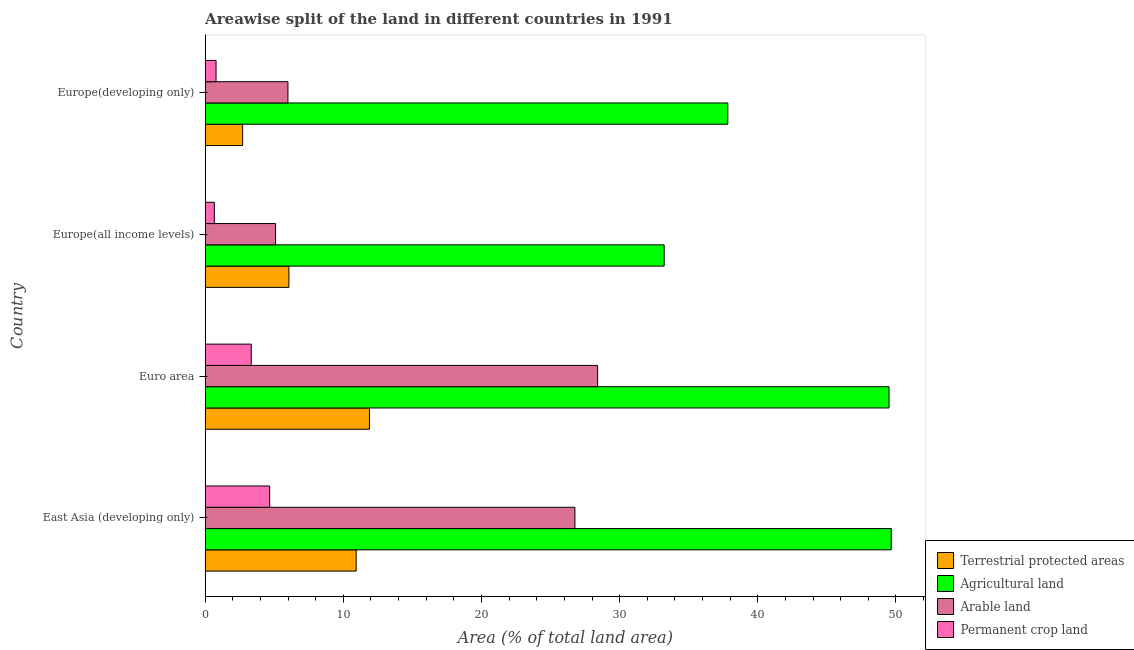How many different coloured bars are there?
Make the answer very short. 4. How many bars are there on the 4th tick from the top?
Make the answer very short. 4. How many bars are there on the 4th tick from the bottom?
Your answer should be very brief. 4. What is the label of the 1st group of bars from the top?
Offer a very short reply. Europe(developing only). What is the percentage of area under agricultural land in Europe(developing only)?
Provide a short and direct response. 37.83. Across all countries, what is the maximum percentage of land under terrestrial protection?
Offer a very short reply. 11.89. Across all countries, what is the minimum percentage of area under permanent crop land?
Make the answer very short. 0.66. In which country was the percentage of land under terrestrial protection minimum?
Keep it short and to the point. Europe(developing only). What is the total percentage of area under arable land in the graph?
Offer a terse response. 66.25. What is the difference between the percentage of area under permanent crop land in East Asia (developing only) and that in Europe(developing only)?
Provide a short and direct response. 3.88. What is the difference between the percentage of area under permanent crop land in Euro area and the percentage of land under terrestrial protection in East Asia (developing only)?
Give a very brief answer. -7.59. What is the average percentage of area under arable land per country?
Ensure brevity in your answer.  16.56. What is the difference between the percentage of area under arable land and percentage of land under terrestrial protection in East Asia (developing only)?
Give a very brief answer. 15.83. What is the ratio of the percentage of area under permanent crop land in East Asia (developing only) to that in Europe(developing only)?
Provide a succinct answer. 5.94. What is the difference between the highest and the second highest percentage of area under arable land?
Give a very brief answer. 1.64. What is the difference between the highest and the lowest percentage of area under arable land?
Keep it short and to the point. 23.31. Is the sum of the percentage of area under permanent crop land in Euro area and Europe(developing only) greater than the maximum percentage of area under agricultural land across all countries?
Give a very brief answer. No. Is it the case that in every country, the sum of the percentage of land under terrestrial protection and percentage of area under arable land is greater than the sum of percentage of area under permanent crop land and percentage of area under agricultural land?
Provide a succinct answer. No. What does the 2nd bar from the top in Euro area represents?
Offer a very short reply. Arable land. What does the 1st bar from the bottom in Europe(all income levels) represents?
Your response must be concise. Terrestrial protected areas. Is it the case that in every country, the sum of the percentage of land under terrestrial protection and percentage of area under agricultural land is greater than the percentage of area under arable land?
Make the answer very short. Yes. How many bars are there?
Make the answer very short. 16. How many countries are there in the graph?
Provide a short and direct response. 4. Does the graph contain any zero values?
Your response must be concise. No. Where does the legend appear in the graph?
Give a very brief answer. Bottom right. How many legend labels are there?
Your answer should be compact. 4. What is the title of the graph?
Your answer should be very brief. Areawise split of the land in different countries in 1991. What is the label or title of the X-axis?
Provide a succinct answer. Area (% of total land area). What is the label or title of the Y-axis?
Your response must be concise. Country. What is the Area (% of total land area) in Terrestrial protected areas in East Asia (developing only)?
Keep it short and to the point. 10.93. What is the Area (% of total land area) in Agricultural land in East Asia (developing only)?
Make the answer very short. 49.66. What is the Area (% of total land area) of Arable land in East Asia (developing only)?
Provide a short and direct response. 26.76. What is the Area (% of total land area) in Permanent crop land in East Asia (developing only)?
Keep it short and to the point. 4.67. What is the Area (% of total land area) of Terrestrial protected areas in Euro area?
Provide a succinct answer. 11.89. What is the Area (% of total land area) in Agricultural land in Euro area?
Offer a very short reply. 49.5. What is the Area (% of total land area) in Arable land in Euro area?
Provide a succinct answer. 28.41. What is the Area (% of total land area) of Permanent crop land in Euro area?
Offer a terse response. 3.33. What is the Area (% of total land area) in Terrestrial protected areas in Europe(all income levels)?
Provide a short and direct response. 6.06. What is the Area (% of total land area) of Agricultural land in Europe(all income levels)?
Your response must be concise. 33.22. What is the Area (% of total land area) in Arable land in Europe(all income levels)?
Give a very brief answer. 5.09. What is the Area (% of total land area) of Permanent crop land in Europe(all income levels)?
Keep it short and to the point. 0.66. What is the Area (% of total land area) of Terrestrial protected areas in Europe(developing only)?
Provide a short and direct response. 2.71. What is the Area (% of total land area) in Agricultural land in Europe(developing only)?
Your answer should be very brief. 37.83. What is the Area (% of total land area) in Arable land in Europe(developing only)?
Give a very brief answer. 5.99. What is the Area (% of total land area) of Permanent crop land in Europe(developing only)?
Make the answer very short. 0.79. Across all countries, what is the maximum Area (% of total land area) in Terrestrial protected areas?
Give a very brief answer. 11.89. Across all countries, what is the maximum Area (% of total land area) in Agricultural land?
Your answer should be very brief. 49.66. Across all countries, what is the maximum Area (% of total land area) of Arable land?
Your response must be concise. 28.41. Across all countries, what is the maximum Area (% of total land area) in Permanent crop land?
Give a very brief answer. 4.67. Across all countries, what is the minimum Area (% of total land area) of Terrestrial protected areas?
Provide a short and direct response. 2.71. Across all countries, what is the minimum Area (% of total land area) of Agricultural land?
Keep it short and to the point. 33.22. Across all countries, what is the minimum Area (% of total land area) in Arable land?
Your answer should be compact. 5.09. Across all countries, what is the minimum Area (% of total land area) in Permanent crop land?
Offer a terse response. 0.66. What is the total Area (% of total land area) of Terrestrial protected areas in the graph?
Give a very brief answer. 31.59. What is the total Area (% of total land area) of Agricultural land in the graph?
Offer a very short reply. 170.21. What is the total Area (% of total land area) of Arable land in the graph?
Your answer should be compact. 66.25. What is the total Area (% of total land area) of Permanent crop land in the graph?
Your answer should be very brief. 9.45. What is the difference between the Area (% of total land area) of Terrestrial protected areas in East Asia (developing only) and that in Euro area?
Provide a short and direct response. -0.96. What is the difference between the Area (% of total land area) of Agricultural land in East Asia (developing only) and that in Euro area?
Give a very brief answer. 0.16. What is the difference between the Area (% of total land area) of Arable land in East Asia (developing only) and that in Euro area?
Your answer should be very brief. -1.64. What is the difference between the Area (% of total land area) in Permanent crop land in East Asia (developing only) and that in Euro area?
Provide a short and direct response. 1.33. What is the difference between the Area (% of total land area) of Terrestrial protected areas in East Asia (developing only) and that in Europe(all income levels)?
Ensure brevity in your answer.  4.87. What is the difference between the Area (% of total land area) of Agricultural land in East Asia (developing only) and that in Europe(all income levels)?
Give a very brief answer. 16.44. What is the difference between the Area (% of total land area) of Arable land in East Asia (developing only) and that in Europe(all income levels)?
Offer a very short reply. 21.67. What is the difference between the Area (% of total land area) in Permanent crop land in East Asia (developing only) and that in Europe(all income levels)?
Ensure brevity in your answer.  4.01. What is the difference between the Area (% of total land area) of Terrestrial protected areas in East Asia (developing only) and that in Europe(developing only)?
Provide a succinct answer. 8.22. What is the difference between the Area (% of total land area) in Agricultural land in East Asia (developing only) and that in Europe(developing only)?
Offer a very short reply. 11.83. What is the difference between the Area (% of total land area) in Arable land in East Asia (developing only) and that in Europe(developing only)?
Offer a very short reply. 20.77. What is the difference between the Area (% of total land area) of Permanent crop land in East Asia (developing only) and that in Europe(developing only)?
Give a very brief answer. 3.88. What is the difference between the Area (% of total land area) of Terrestrial protected areas in Euro area and that in Europe(all income levels)?
Keep it short and to the point. 5.83. What is the difference between the Area (% of total land area) in Agricultural land in Euro area and that in Europe(all income levels)?
Offer a very short reply. 16.28. What is the difference between the Area (% of total land area) of Arable land in Euro area and that in Europe(all income levels)?
Offer a terse response. 23.31. What is the difference between the Area (% of total land area) of Permanent crop land in Euro area and that in Europe(all income levels)?
Offer a terse response. 2.67. What is the difference between the Area (% of total land area) in Terrestrial protected areas in Euro area and that in Europe(developing only)?
Your response must be concise. 9.18. What is the difference between the Area (% of total land area) of Agricultural land in Euro area and that in Europe(developing only)?
Ensure brevity in your answer.  11.67. What is the difference between the Area (% of total land area) in Arable land in Euro area and that in Europe(developing only)?
Offer a very short reply. 22.42. What is the difference between the Area (% of total land area) of Permanent crop land in Euro area and that in Europe(developing only)?
Your response must be concise. 2.55. What is the difference between the Area (% of total land area) of Terrestrial protected areas in Europe(all income levels) and that in Europe(developing only)?
Make the answer very short. 3.35. What is the difference between the Area (% of total land area) in Agricultural land in Europe(all income levels) and that in Europe(developing only)?
Your answer should be very brief. -4.61. What is the difference between the Area (% of total land area) of Arable land in Europe(all income levels) and that in Europe(developing only)?
Keep it short and to the point. -0.89. What is the difference between the Area (% of total land area) of Permanent crop land in Europe(all income levels) and that in Europe(developing only)?
Give a very brief answer. -0.12. What is the difference between the Area (% of total land area) of Terrestrial protected areas in East Asia (developing only) and the Area (% of total land area) of Agricultural land in Euro area?
Keep it short and to the point. -38.57. What is the difference between the Area (% of total land area) in Terrestrial protected areas in East Asia (developing only) and the Area (% of total land area) in Arable land in Euro area?
Offer a very short reply. -17.48. What is the difference between the Area (% of total land area) in Terrestrial protected areas in East Asia (developing only) and the Area (% of total land area) in Permanent crop land in Euro area?
Your answer should be compact. 7.59. What is the difference between the Area (% of total land area) of Agricultural land in East Asia (developing only) and the Area (% of total land area) of Arable land in Euro area?
Ensure brevity in your answer.  21.25. What is the difference between the Area (% of total land area) in Agricultural land in East Asia (developing only) and the Area (% of total land area) in Permanent crop land in Euro area?
Keep it short and to the point. 46.32. What is the difference between the Area (% of total land area) in Arable land in East Asia (developing only) and the Area (% of total land area) in Permanent crop land in Euro area?
Your answer should be compact. 23.43. What is the difference between the Area (% of total land area) in Terrestrial protected areas in East Asia (developing only) and the Area (% of total land area) in Agricultural land in Europe(all income levels)?
Offer a terse response. -22.3. What is the difference between the Area (% of total land area) in Terrestrial protected areas in East Asia (developing only) and the Area (% of total land area) in Arable land in Europe(all income levels)?
Your answer should be compact. 5.83. What is the difference between the Area (% of total land area) of Terrestrial protected areas in East Asia (developing only) and the Area (% of total land area) of Permanent crop land in Europe(all income levels)?
Provide a succinct answer. 10.27. What is the difference between the Area (% of total land area) in Agricultural land in East Asia (developing only) and the Area (% of total land area) in Arable land in Europe(all income levels)?
Keep it short and to the point. 44.56. What is the difference between the Area (% of total land area) in Agricultural land in East Asia (developing only) and the Area (% of total land area) in Permanent crop land in Europe(all income levels)?
Give a very brief answer. 49. What is the difference between the Area (% of total land area) of Arable land in East Asia (developing only) and the Area (% of total land area) of Permanent crop land in Europe(all income levels)?
Make the answer very short. 26.1. What is the difference between the Area (% of total land area) in Terrestrial protected areas in East Asia (developing only) and the Area (% of total land area) in Agricultural land in Europe(developing only)?
Offer a terse response. -26.9. What is the difference between the Area (% of total land area) in Terrestrial protected areas in East Asia (developing only) and the Area (% of total land area) in Arable land in Europe(developing only)?
Your answer should be compact. 4.94. What is the difference between the Area (% of total land area) of Terrestrial protected areas in East Asia (developing only) and the Area (% of total land area) of Permanent crop land in Europe(developing only)?
Offer a very short reply. 10.14. What is the difference between the Area (% of total land area) in Agricultural land in East Asia (developing only) and the Area (% of total land area) in Arable land in Europe(developing only)?
Give a very brief answer. 43.67. What is the difference between the Area (% of total land area) of Agricultural land in East Asia (developing only) and the Area (% of total land area) of Permanent crop land in Europe(developing only)?
Ensure brevity in your answer.  48.87. What is the difference between the Area (% of total land area) of Arable land in East Asia (developing only) and the Area (% of total land area) of Permanent crop land in Europe(developing only)?
Your answer should be compact. 25.98. What is the difference between the Area (% of total land area) of Terrestrial protected areas in Euro area and the Area (% of total land area) of Agricultural land in Europe(all income levels)?
Offer a very short reply. -21.33. What is the difference between the Area (% of total land area) in Terrestrial protected areas in Euro area and the Area (% of total land area) in Arable land in Europe(all income levels)?
Your answer should be very brief. 6.8. What is the difference between the Area (% of total land area) of Terrestrial protected areas in Euro area and the Area (% of total land area) of Permanent crop land in Europe(all income levels)?
Provide a short and direct response. 11.23. What is the difference between the Area (% of total land area) of Agricultural land in Euro area and the Area (% of total land area) of Arable land in Europe(all income levels)?
Offer a very short reply. 44.41. What is the difference between the Area (% of total land area) of Agricultural land in Euro area and the Area (% of total land area) of Permanent crop land in Europe(all income levels)?
Provide a short and direct response. 48.84. What is the difference between the Area (% of total land area) of Arable land in Euro area and the Area (% of total land area) of Permanent crop land in Europe(all income levels)?
Your answer should be very brief. 27.74. What is the difference between the Area (% of total land area) in Terrestrial protected areas in Euro area and the Area (% of total land area) in Agricultural land in Europe(developing only)?
Make the answer very short. -25.94. What is the difference between the Area (% of total land area) of Terrestrial protected areas in Euro area and the Area (% of total land area) of Arable land in Europe(developing only)?
Make the answer very short. 5.9. What is the difference between the Area (% of total land area) in Terrestrial protected areas in Euro area and the Area (% of total land area) in Permanent crop land in Europe(developing only)?
Keep it short and to the point. 11.11. What is the difference between the Area (% of total land area) in Agricultural land in Euro area and the Area (% of total land area) in Arable land in Europe(developing only)?
Your answer should be very brief. 43.51. What is the difference between the Area (% of total land area) in Agricultural land in Euro area and the Area (% of total land area) in Permanent crop land in Europe(developing only)?
Offer a very short reply. 48.71. What is the difference between the Area (% of total land area) of Arable land in Euro area and the Area (% of total land area) of Permanent crop land in Europe(developing only)?
Keep it short and to the point. 27.62. What is the difference between the Area (% of total land area) of Terrestrial protected areas in Europe(all income levels) and the Area (% of total land area) of Agricultural land in Europe(developing only)?
Your response must be concise. -31.77. What is the difference between the Area (% of total land area) in Terrestrial protected areas in Europe(all income levels) and the Area (% of total land area) in Arable land in Europe(developing only)?
Give a very brief answer. 0.07. What is the difference between the Area (% of total land area) in Terrestrial protected areas in Europe(all income levels) and the Area (% of total land area) in Permanent crop land in Europe(developing only)?
Provide a short and direct response. 5.27. What is the difference between the Area (% of total land area) in Agricultural land in Europe(all income levels) and the Area (% of total land area) in Arable land in Europe(developing only)?
Provide a succinct answer. 27.23. What is the difference between the Area (% of total land area) of Agricultural land in Europe(all income levels) and the Area (% of total land area) of Permanent crop land in Europe(developing only)?
Give a very brief answer. 32.44. What is the difference between the Area (% of total land area) in Arable land in Europe(all income levels) and the Area (% of total land area) in Permanent crop land in Europe(developing only)?
Your answer should be very brief. 4.31. What is the average Area (% of total land area) of Terrestrial protected areas per country?
Your response must be concise. 7.9. What is the average Area (% of total land area) in Agricultural land per country?
Offer a terse response. 42.55. What is the average Area (% of total land area) of Arable land per country?
Ensure brevity in your answer.  16.56. What is the average Area (% of total land area) of Permanent crop land per country?
Offer a very short reply. 2.36. What is the difference between the Area (% of total land area) in Terrestrial protected areas and Area (% of total land area) in Agricultural land in East Asia (developing only)?
Give a very brief answer. -38.73. What is the difference between the Area (% of total land area) of Terrestrial protected areas and Area (% of total land area) of Arable land in East Asia (developing only)?
Ensure brevity in your answer.  -15.83. What is the difference between the Area (% of total land area) of Terrestrial protected areas and Area (% of total land area) of Permanent crop land in East Asia (developing only)?
Provide a succinct answer. 6.26. What is the difference between the Area (% of total land area) of Agricultural land and Area (% of total land area) of Arable land in East Asia (developing only)?
Offer a very short reply. 22.9. What is the difference between the Area (% of total land area) in Agricultural land and Area (% of total land area) in Permanent crop land in East Asia (developing only)?
Provide a short and direct response. 44.99. What is the difference between the Area (% of total land area) in Arable land and Area (% of total land area) in Permanent crop land in East Asia (developing only)?
Offer a terse response. 22.09. What is the difference between the Area (% of total land area) of Terrestrial protected areas and Area (% of total land area) of Agricultural land in Euro area?
Provide a short and direct response. -37.61. What is the difference between the Area (% of total land area) of Terrestrial protected areas and Area (% of total land area) of Arable land in Euro area?
Give a very brief answer. -16.51. What is the difference between the Area (% of total land area) of Terrestrial protected areas and Area (% of total land area) of Permanent crop land in Euro area?
Give a very brief answer. 8.56. What is the difference between the Area (% of total land area) of Agricultural land and Area (% of total land area) of Arable land in Euro area?
Provide a succinct answer. 21.09. What is the difference between the Area (% of total land area) of Agricultural land and Area (% of total land area) of Permanent crop land in Euro area?
Keep it short and to the point. 46.16. What is the difference between the Area (% of total land area) in Arable land and Area (% of total land area) in Permanent crop land in Euro area?
Provide a short and direct response. 25.07. What is the difference between the Area (% of total land area) of Terrestrial protected areas and Area (% of total land area) of Agricultural land in Europe(all income levels)?
Ensure brevity in your answer.  -27.16. What is the difference between the Area (% of total land area) in Terrestrial protected areas and Area (% of total land area) in Arable land in Europe(all income levels)?
Ensure brevity in your answer.  0.97. What is the difference between the Area (% of total land area) of Terrestrial protected areas and Area (% of total land area) of Permanent crop land in Europe(all income levels)?
Keep it short and to the point. 5.4. What is the difference between the Area (% of total land area) of Agricultural land and Area (% of total land area) of Arable land in Europe(all income levels)?
Keep it short and to the point. 28.13. What is the difference between the Area (% of total land area) in Agricultural land and Area (% of total land area) in Permanent crop land in Europe(all income levels)?
Your response must be concise. 32.56. What is the difference between the Area (% of total land area) in Arable land and Area (% of total land area) in Permanent crop land in Europe(all income levels)?
Your response must be concise. 4.43. What is the difference between the Area (% of total land area) of Terrestrial protected areas and Area (% of total land area) of Agricultural land in Europe(developing only)?
Offer a very short reply. -35.12. What is the difference between the Area (% of total land area) in Terrestrial protected areas and Area (% of total land area) in Arable land in Europe(developing only)?
Ensure brevity in your answer.  -3.28. What is the difference between the Area (% of total land area) of Terrestrial protected areas and Area (% of total land area) of Permanent crop land in Europe(developing only)?
Keep it short and to the point. 1.92. What is the difference between the Area (% of total land area) in Agricultural land and Area (% of total land area) in Arable land in Europe(developing only)?
Your response must be concise. 31.84. What is the difference between the Area (% of total land area) in Agricultural land and Area (% of total land area) in Permanent crop land in Europe(developing only)?
Ensure brevity in your answer.  37.04. What is the difference between the Area (% of total land area) in Arable land and Area (% of total land area) in Permanent crop land in Europe(developing only)?
Provide a short and direct response. 5.2. What is the ratio of the Area (% of total land area) in Terrestrial protected areas in East Asia (developing only) to that in Euro area?
Provide a short and direct response. 0.92. What is the ratio of the Area (% of total land area) in Arable land in East Asia (developing only) to that in Euro area?
Provide a short and direct response. 0.94. What is the ratio of the Area (% of total land area) in Permanent crop land in East Asia (developing only) to that in Euro area?
Your answer should be very brief. 1.4. What is the ratio of the Area (% of total land area) in Terrestrial protected areas in East Asia (developing only) to that in Europe(all income levels)?
Give a very brief answer. 1.8. What is the ratio of the Area (% of total land area) in Agricultural land in East Asia (developing only) to that in Europe(all income levels)?
Provide a short and direct response. 1.49. What is the ratio of the Area (% of total land area) in Arable land in East Asia (developing only) to that in Europe(all income levels)?
Provide a succinct answer. 5.25. What is the ratio of the Area (% of total land area) in Permanent crop land in East Asia (developing only) to that in Europe(all income levels)?
Your answer should be very brief. 7.05. What is the ratio of the Area (% of total land area) in Terrestrial protected areas in East Asia (developing only) to that in Europe(developing only)?
Your answer should be very brief. 4.03. What is the ratio of the Area (% of total land area) of Agricultural land in East Asia (developing only) to that in Europe(developing only)?
Your answer should be very brief. 1.31. What is the ratio of the Area (% of total land area) in Arable land in East Asia (developing only) to that in Europe(developing only)?
Your answer should be compact. 4.47. What is the ratio of the Area (% of total land area) in Permanent crop land in East Asia (developing only) to that in Europe(developing only)?
Your answer should be very brief. 5.94. What is the ratio of the Area (% of total land area) of Terrestrial protected areas in Euro area to that in Europe(all income levels)?
Ensure brevity in your answer.  1.96. What is the ratio of the Area (% of total land area) of Agricultural land in Euro area to that in Europe(all income levels)?
Your answer should be very brief. 1.49. What is the ratio of the Area (% of total land area) of Arable land in Euro area to that in Europe(all income levels)?
Your answer should be very brief. 5.58. What is the ratio of the Area (% of total land area) in Permanent crop land in Euro area to that in Europe(all income levels)?
Provide a succinct answer. 5.04. What is the ratio of the Area (% of total land area) in Terrestrial protected areas in Euro area to that in Europe(developing only)?
Provide a short and direct response. 4.39. What is the ratio of the Area (% of total land area) in Agricultural land in Euro area to that in Europe(developing only)?
Offer a terse response. 1.31. What is the ratio of the Area (% of total land area) in Arable land in Euro area to that in Europe(developing only)?
Offer a terse response. 4.74. What is the ratio of the Area (% of total land area) of Permanent crop land in Euro area to that in Europe(developing only)?
Give a very brief answer. 4.24. What is the ratio of the Area (% of total land area) in Terrestrial protected areas in Europe(all income levels) to that in Europe(developing only)?
Offer a terse response. 2.24. What is the ratio of the Area (% of total land area) in Agricultural land in Europe(all income levels) to that in Europe(developing only)?
Keep it short and to the point. 0.88. What is the ratio of the Area (% of total land area) of Arable land in Europe(all income levels) to that in Europe(developing only)?
Ensure brevity in your answer.  0.85. What is the ratio of the Area (% of total land area) in Permanent crop land in Europe(all income levels) to that in Europe(developing only)?
Provide a short and direct response. 0.84. What is the difference between the highest and the second highest Area (% of total land area) in Terrestrial protected areas?
Offer a terse response. 0.96. What is the difference between the highest and the second highest Area (% of total land area) of Agricultural land?
Your answer should be very brief. 0.16. What is the difference between the highest and the second highest Area (% of total land area) of Arable land?
Offer a terse response. 1.64. What is the difference between the highest and the second highest Area (% of total land area) in Permanent crop land?
Give a very brief answer. 1.33. What is the difference between the highest and the lowest Area (% of total land area) of Terrestrial protected areas?
Ensure brevity in your answer.  9.18. What is the difference between the highest and the lowest Area (% of total land area) in Agricultural land?
Give a very brief answer. 16.44. What is the difference between the highest and the lowest Area (% of total land area) in Arable land?
Provide a short and direct response. 23.31. What is the difference between the highest and the lowest Area (% of total land area) in Permanent crop land?
Ensure brevity in your answer.  4.01. 